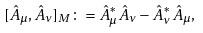<formula> <loc_0><loc_0><loc_500><loc_500>[ \hat { A } _ { \mu } , \hat { A } _ { \nu } ] _ { M } \colon = \hat { A } _ { \mu } ^ { * } \hat { A } _ { \nu } - \hat { A } _ { \nu } ^ { * } \hat { A } _ { \mu } ,</formula> 